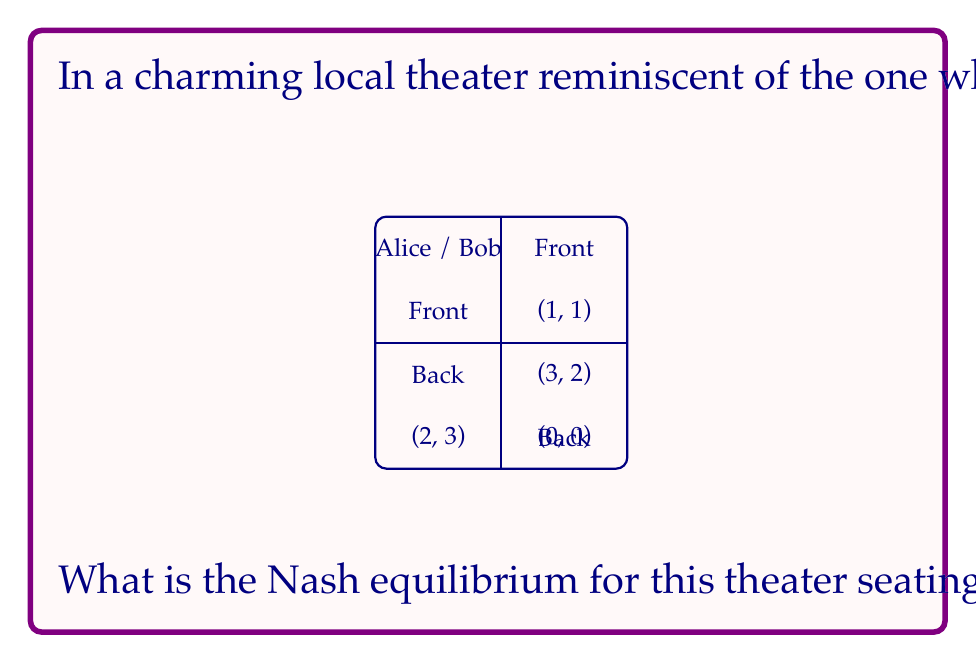Give your solution to this math problem. To find the Nash equilibrium, we need to analyze each player's best response to the other player's strategy.

1. If Alice chooses Front:
   - Bob's best response is Back (payoff 3 > 1)
2. If Alice chooses Back:
   - Bob's best response is Front (payoff 2 > 0)
3. If Bob chooses Front:
   - Alice's best response is Back (payoff 2 > 1)
4. If Bob chooses Back:
   - Alice's best response is Front (payoff 3 > 0)

We can see that there is no pure strategy Nash equilibrium, as no pair of strategies is a best response to each other.

Therefore, we need to look for a mixed strategy Nash equilibrium. Let's define:
$p$ = probability of Alice choosing Front
$q$ = probability of Bob choosing Front

For a mixed strategy equilibrium, each player must be indifferent between their pure strategies:

For Alice:
$1q + 3(1-q) = 2q + 0(1-q)$
$1q + 3 - 3q = 2q$
$3 - 2q = 2q$
$3 = 4q$
$q = \frac{3}{4}$

For Bob:
$1p + 2(1-p) = 3p + 0(1-p)$
$1p + 2 - 2p = 3p$
$2 - p = 3p$
$2 = 4p$
$p = \frac{1}{2}$

Thus, the mixed strategy Nash equilibrium is:
Alice chooses Front with probability $\frac{1}{2}$ and Back with probability $\frac{1}{2}$
Bob chooses Front with probability $\frac{3}{4}$ and Back with probability $\frac{1}{4}$
Answer: $(\frac{1}{2}\text{ Front}, \frac{1}{2}\text{ Back})$ for Alice; $(\frac{3}{4}\text{ Front}, \frac{1}{4}\text{ Back})$ for Bob 